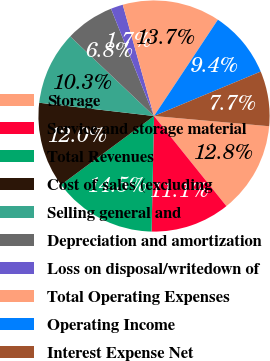<chart> <loc_0><loc_0><loc_500><loc_500><pie_chart><fcel>Storage<fcel>Service and storage material<fcel>Total Revenues<fcel>Cost of sales (excluding<fcel>Selling general and<fcel>Depreciation and amortization<fcel>Loss on disposal/writedown of<fcel>Total Operating Expenses<fcel>Operating Income<fcel>Interest Expense Net<nl><fcel>12.82%<fcel>11.11%<fcel>14.53%<fcel>11.97%<fcel>10.26%<fcel>6.84%<fcel>1.71%<fcel>13.68%<fcel>9.4%<fcel>7.69%<nl></chart> 